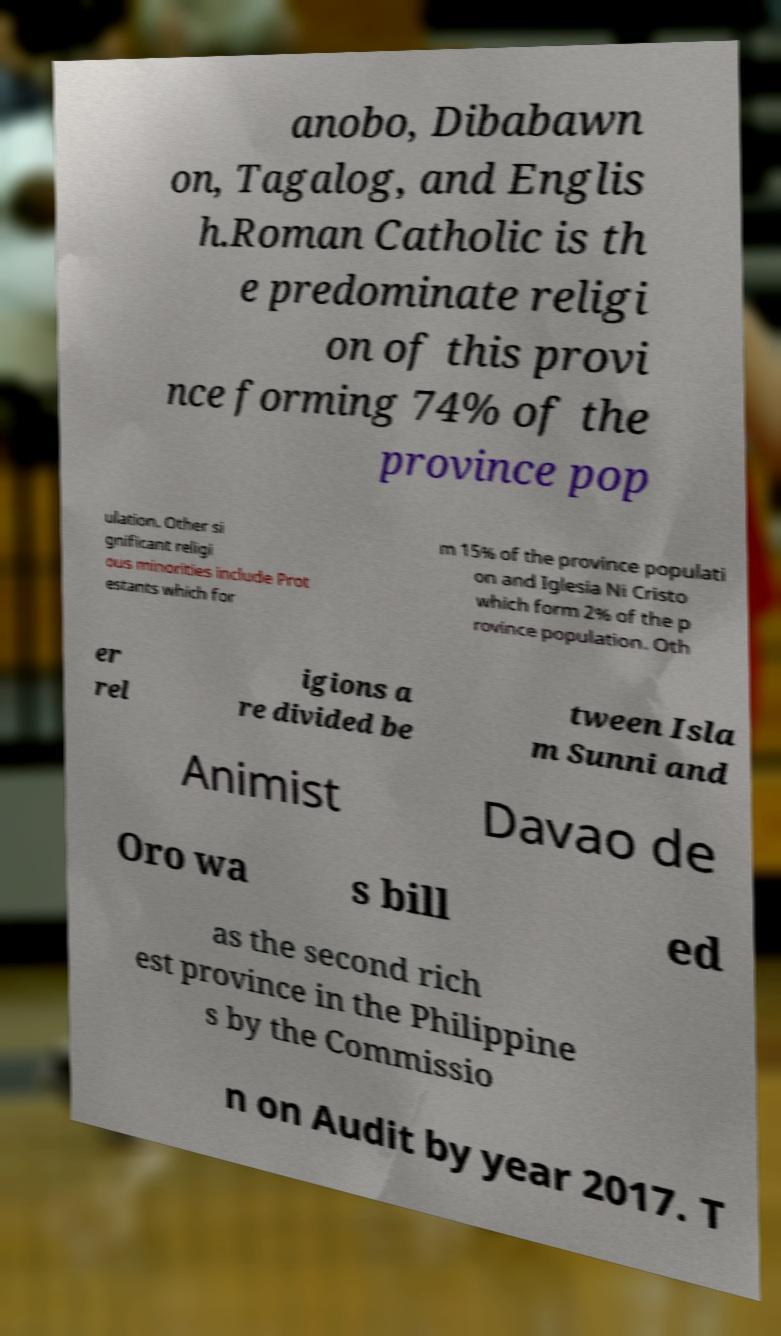For documentation purposes, I need the text within this image transcribed. Could you provide that? anobo, Dibabawn on, Tagalog, and Englis h.Roman Catholic is th e predominate religi on of this provi nce forming 74% of the province pop ulation. Other si gnificant religi ous minorities include Prot estants which for m 15% of the province populati on and Iglesia Ni Cristo which form 2% of the p rovince population. Oth er rel igions a re divided be tween Isla m Sunni and Animist Davao de Oro wa s bill ed as the second rich est province in the Philippine s by the Commissio n on Audit by year 2017. T 